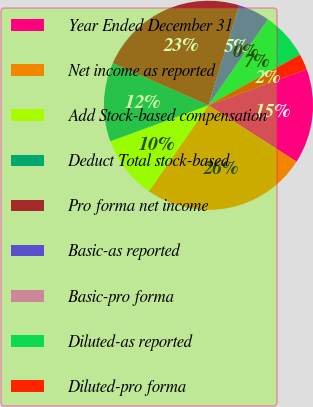<chart> <loc_0><loc_0><loc_500><loc_500><pie_chart><fcel>Year Ended December 31<fcel>Net income as reported<fcel>Add Stock-based compensation<fcel>Deduct Total stock-based<fcel>Pro forma net income<fcel>Basic-as reported<fcel>Basic-pro forma<fcel>Diluted-as reported<fcel>Diluted-pro forma<nl><fcel>14.64%<fcel>25.59%<fcel>9.76%<fcel>12.2%<fcel>23.15%<fcel>4.89%<fcel>0.01%<fcel>7.32%<fcel>2.45%<nl></chart> 